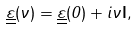Convert formula to latex. <formula><loc_0><loc_0><loc_500><loc_500>\underline { \underline { \varepsilon } } ( \nu ) = \underline { \underline { \varepsilon } } ( 0 ) + i \nu \mathbf I ,</formula> 